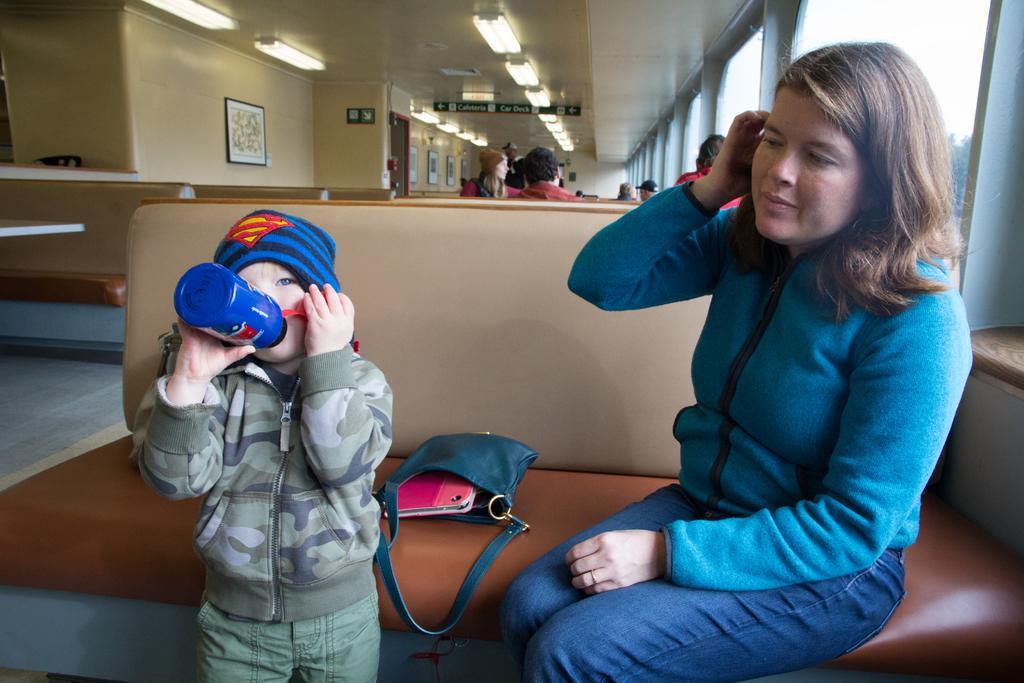Could you give a brief overview of what you see in this image? Here is a women sitting on the couch,here is a bag placed on the couch. This kid is standing and drinking water. At background I can see few people standing and sitting. This is a photo frame attached to the wall and these are the lights attached to the rooftop. 